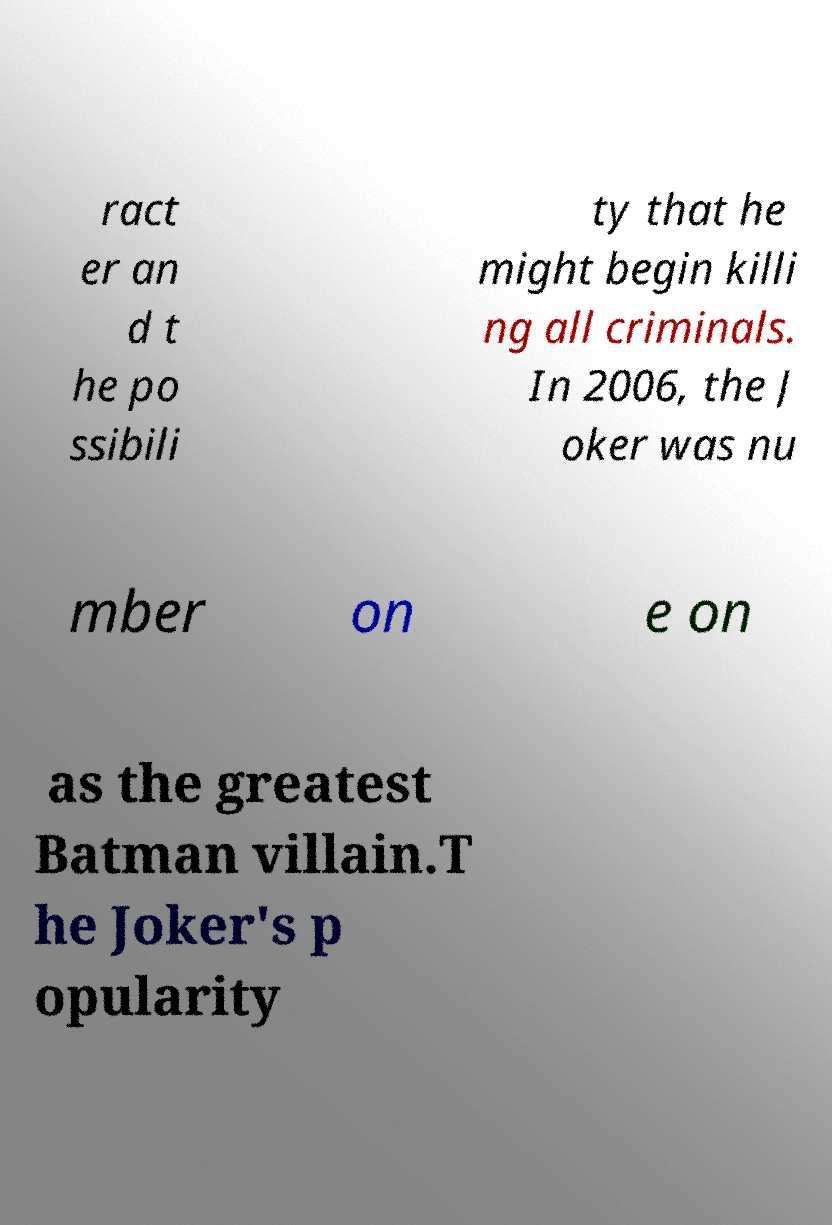Could you assist in decoding the text presented in this image and type it out clearly? ract er an d t he po ssibili ty that he might begin killi ng all criminals. In 2006, the J oker was nu mber on e on as the greatest Batman villain.T he Joker's p opularity 